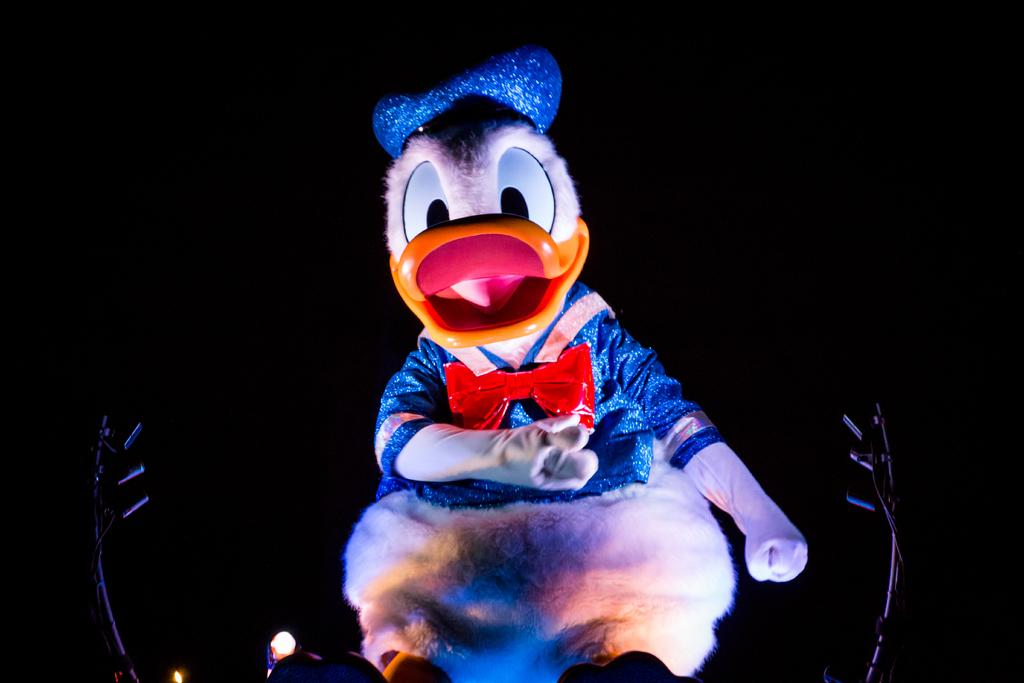What is the main subject of the image? There is a Mickey Mouse doll in the image. Where is the Mickey Mouse doll located in the image? The doll is at the center of the image. What else can be seen in the image besides the doll? There are lights beside the doll. What type of cakes are being served on the table in the image? There is no table or cakes present in the image; it features a Mickey Mouse doll and lights. 